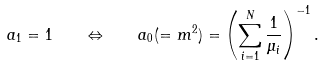<formula> <loc_0><loc_0><loc_500><loc_500>a _ { 1 } = 1 \quad \Leftrightarrow \quad a _ { 0 } ( = m ^ { 2 } ) = \left ( \sum _ { i = 1 } ^ { N } \frac { 1 } { \mu _ { i } } \right ) ^ { - 1 } .</formula> 